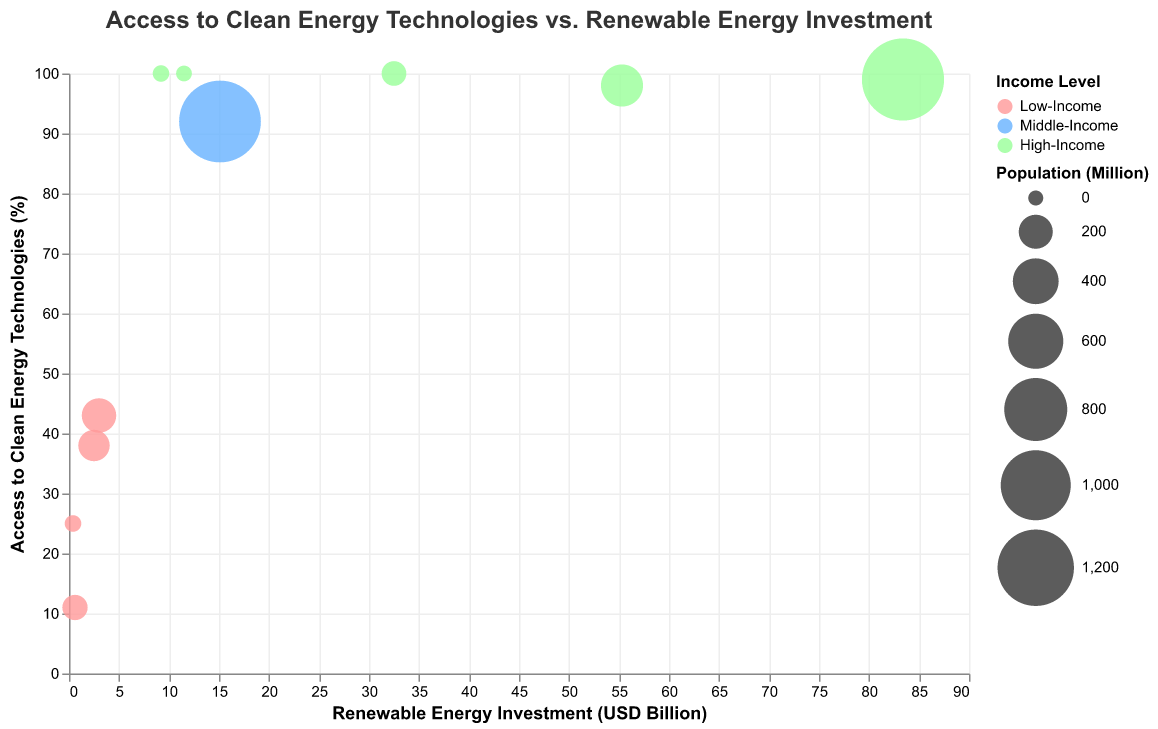What is the title of the figure? The title of the figure is displayed prominently at the top and provides an overview of what the chart is about.
Answer: Access to Clean Energy Technologies vs. Renewable Energy Investment What does the color of the bubbles represent? The color of the bubbles in the chart indicates the income level of the countries.
Answer: Income Level Which country has the highest access to clean energy technologies? By locating the bubble with the highest y-axis value and referring to the country name in the tooltip or color legend, you can determine this.
Answer: Germany, Norway, and Sweden (all have 100%) How many low-income countries are shown in the chart? By counting all the bubbles colored in the same way that represents low-income countries in the legend, this can be found.
Answer: 4 Which country has the largest population of all the countries displayed? By identifying the largest bubble in size, then referring to the country name in the tooltip or legend, the answer is evident.
Answer: China What is the difference in renewable energy investment between the United States and Bangladesh? Find the x-axis values for both countries and subtract the smaller value from the larger one: 55.3 (US) - 2.5 (Bangladesh).
Answer: 52.8 USD Billion What is the average access to clean energy technologies for the low-income countries listed? The access numbers for low-income countries are 38, 43, 25, and 11. Calculate the sum and then divide by the number of values: (38 + 43 + 25 + 11) / 4.
Answer: 29.25% Does India have greater access to clean energy technologies than Nigeria? Compare the y-axis value for both countries. India’s value is 92%, and Nigeria’s value is 43%.
Answer: Yes Which high-income country has the lowest renewable energy investment? By examining the bubbles colored for the high-income group and determining the smallest x-axis value among them.
Answer: Sweden What is the total population of the high-income countries shown? Sum the population values of high-income countries: 1393 (China) + 331 (US) + 83 (Germany) + 5.4 (Norway) + 10.4 (Sweden).
Answer: 1822.8 million 